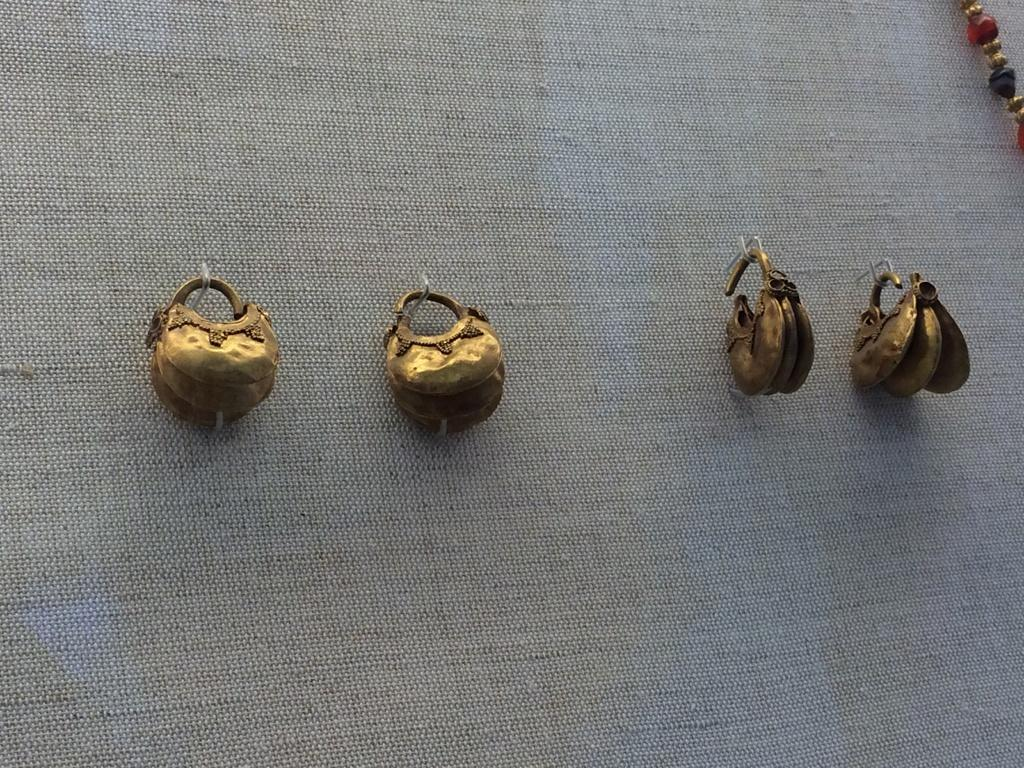What is present on the wall in the image? There are objects hanging on the wall in the image. What advice does the grandmother give to the cub during the competition in the image? There is no grandmother, cub, or competition present in the image. 